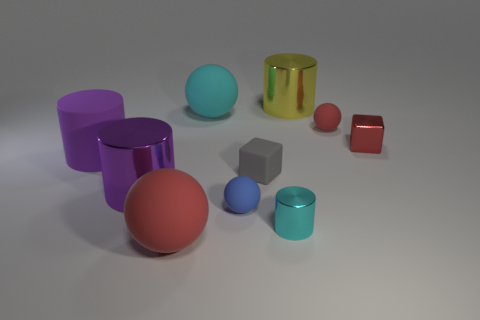How many spheres are either small blue rubber objects or big cyan things?
Provide a succinct answer. 2. There is a rubber object that is left of the small gray matte thing and behind the small red metallic cube; what shape is it?
Your answer should be very brief. Sphere. Are there any blue rubber cylinders that have the same size as the cyan rubber object?
Provide a short and direct response. No. What number of objects are small things to the left of the small metallic cylinder or small cylinders?
Offer a terse response. 3. Does the cyan cylinder have the same material as the large sphere behind the gray cube?
Offer a terse response. No. What number of other objects are there of the same shape as the tiny blue object?
Give a very brief answer. 3. How many objects are metallic objects that are in front of the large cyan thing or large matte balls behind the tiny red metallic thing?
Offer a very short reply. 4. What number of other things are the same color as the large rubber cylinder?
Offer a very short reply. 1. Is the number of gray matte cubes that are right of the gray block less than the number of shiny cylinders that are behind the small blue ball?
Offer a very short reply. Yes. What number of small cubes are there?
Your response must be concise. 2. 